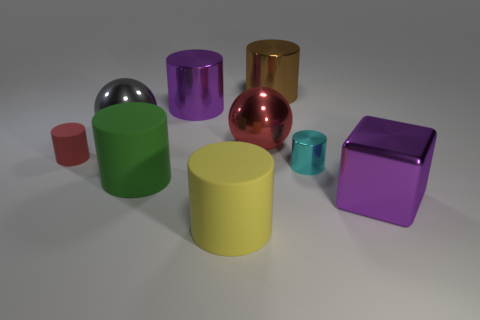How many blocks are the same color as the small rubber object?
Offer a very short reply. 0. How many small objects are either gray metallic things or red rubber cylinders?
Ensure brevity in your answer.  1. Does the red object that is on the left side of the red metallic sphere have the same material as the large brown object?
Give a very brief answer. No. There is a object to the right of the small metallic cylinder; what is its color?
Provide a succinct answer. Purple. Is there another green thing of the same size as the green thing?
Offer a very short reply. No. There is a cyan cylinder that is the same size as the red rubber object; what is its material?
Your answer should be compact. Metal. Does the brown cylinder have the same size as the purple thing in front of the large red metallic thing?
Your answer should be compact. Yes. There is a red object that is in front of the big red ball; what is its material?
Provide a short and direct response. Rubber. Are there an equal number of objects left of the small cyan object and things?
Make the answer very short. No. Do the block and the purple shiny cylinder have the same size?
Provide a succinct answer. Yes. 